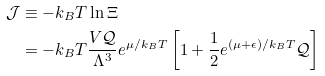Convert formula to latex. <formula><loc_0><loc_0><loc_500><loc_500>\mathcal { J } & \equiv - k _ { B } T \ln \Xi \\ & = - k _ { B } T \frac { V \mathcal { Q } } { \Lambda ^ { 3 } } e ^ { \mu / k _ { B } T } \left [ 1 + \frac { 1 } { 2 } e ^ { ( \mu + \epsilon ) / k _ { B } T } \mathcal { Q } \right ]</formula> 